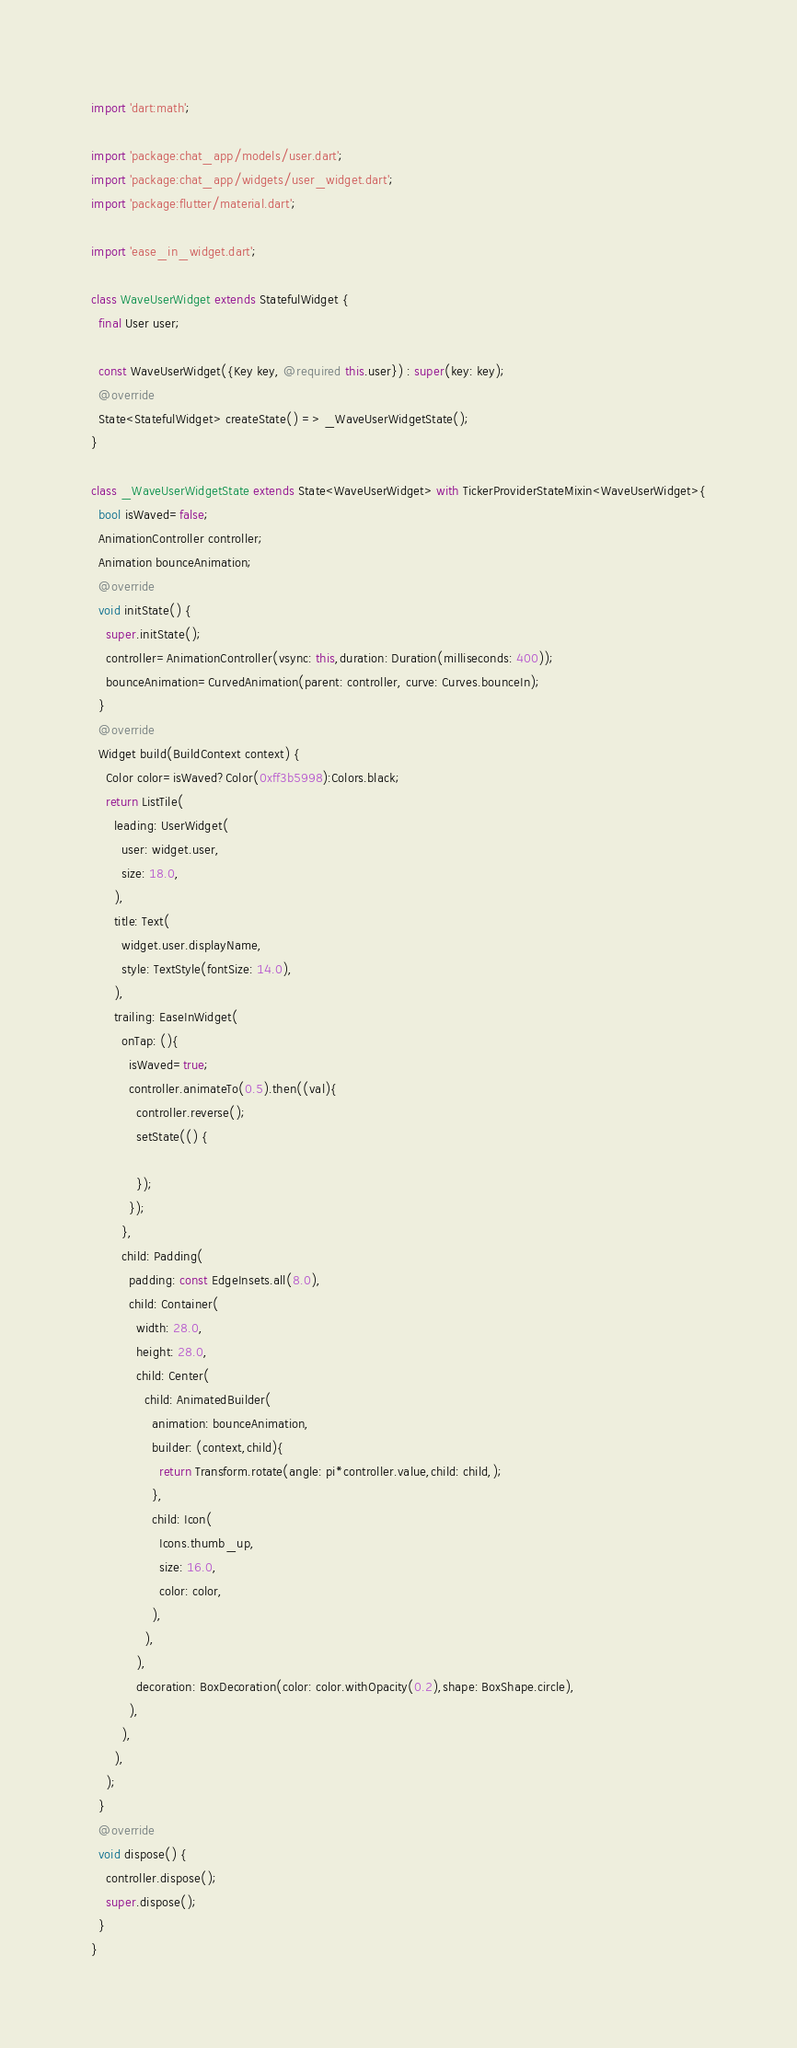<code> <loc_0><loc_0><loc_500><loc_500><_Dart_>import 'dart:math';

import 'package:chat_app/models/user.dart';
import 'package:chat_app/widgets/user_widget.dart';
import 'package:flutter/material.dart';

import 'ease_in_widget.dart';

class WaveUserWidget extends StatefulWidget {
  final User user;

  const WaveUserWidget({Key key, @required this.user}) : super(key: key);
  @override
  State<StatefulWidget> createState() => _WaveUserWidgetState();
}

class _WaveUserWidgetState extends State<WaveUserWidget> with TickerProviderStateMixin<WaveUserWidget>{
  bool isWaved=false;
  AnimationController controller;
  Animation bounceAnimation;
  @override
  void initState() {
    super.initState();
    controller=AnimationController(vsync: this,duration: Duration(milliseconds: 400));
    bounceAnimation=CurvedAnimation(parent: controller, curve: Curves.bounceIn);
  }
  @override
  Widget build(BuildContext context) {
    Color color=isWaved?Color(0xff3b5998):Colors.black;
    return ListTile(
      leading: UserWidget(
        user: widget.user,
        size: 18.0,
      ),
      title: Text(
        widget.user.displayName,
        style: TextStyle(fontSize: 14.0),
      ),
      trailing: EaseInWidget(
        onTap: (){
          isWaved=true;
          controller.animateTo(0.5).then((val){
            controller.reverse();
            setState(() {

            });
          });
        },
        child: Padding(
          padding: const EdgeInsets.all(8.0),
          child: Container(
            width: 28.0,
            height: 28.0,
            child: Center(
              child: AnimatedBuilder(
                animation: bounceAnimation,
                builder: (context,child){
                  return Transform.rotate(angle: pi*controller.value,child: child,);
                },
                child: Icon(
                  Icons.thumb_up,
                  size: 16.0,
                  color: color,
                ),
              ),
            ),
            decoration: BoxDecoration(color: color.withOpacity(0.2),shape: BoxShape.circle),
          ),
        ),
      ),
    );
  }
  @override
  void dispose() {
    controller.dispose();
    super.dispose();
  }
}
</code> 